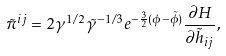<formula> <loc_0><loc_0><loc_500><loc_500>\tilde { \pi } ^ { i j } = 2 \gamma ^ { 1 / 2 } \tilde { \gamma } ^ { - 1 / 3 } e ^ { - \frac { 3 } { 2 } ( \phi - \tilde { \phi } ) } \frac { \partial H } { \partial \tilde { h } _ { i j } } ,</formula> 